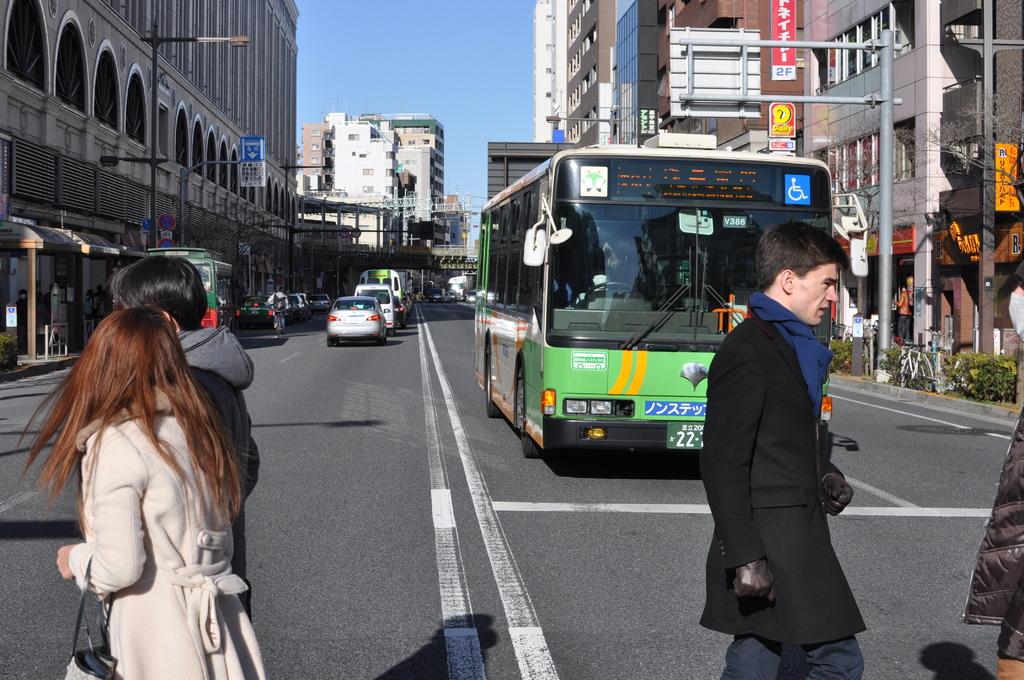What are the first two numbers of the bus license plate?
Offer a terse response. 22. 